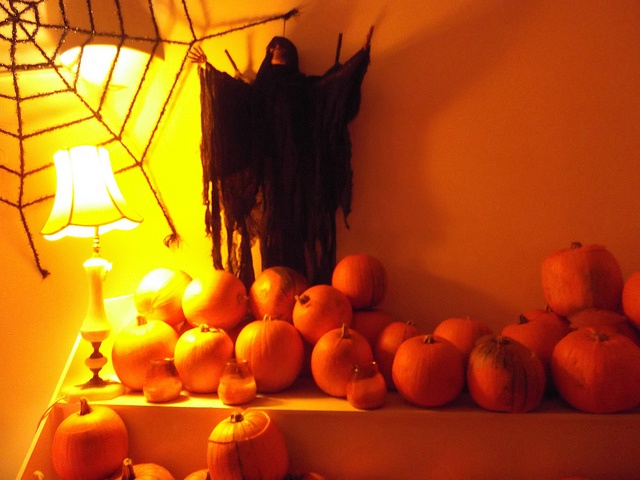Describe the objects in this image and their specific colors. I can see orange in orange, brown, maroon, and red tones, orange in orange, maroon, and red tones, orange in orange, brown, red, and gold tones, orange in orange, red, and yellow tones, and orange in orange, maroon, and red tones in this image. 